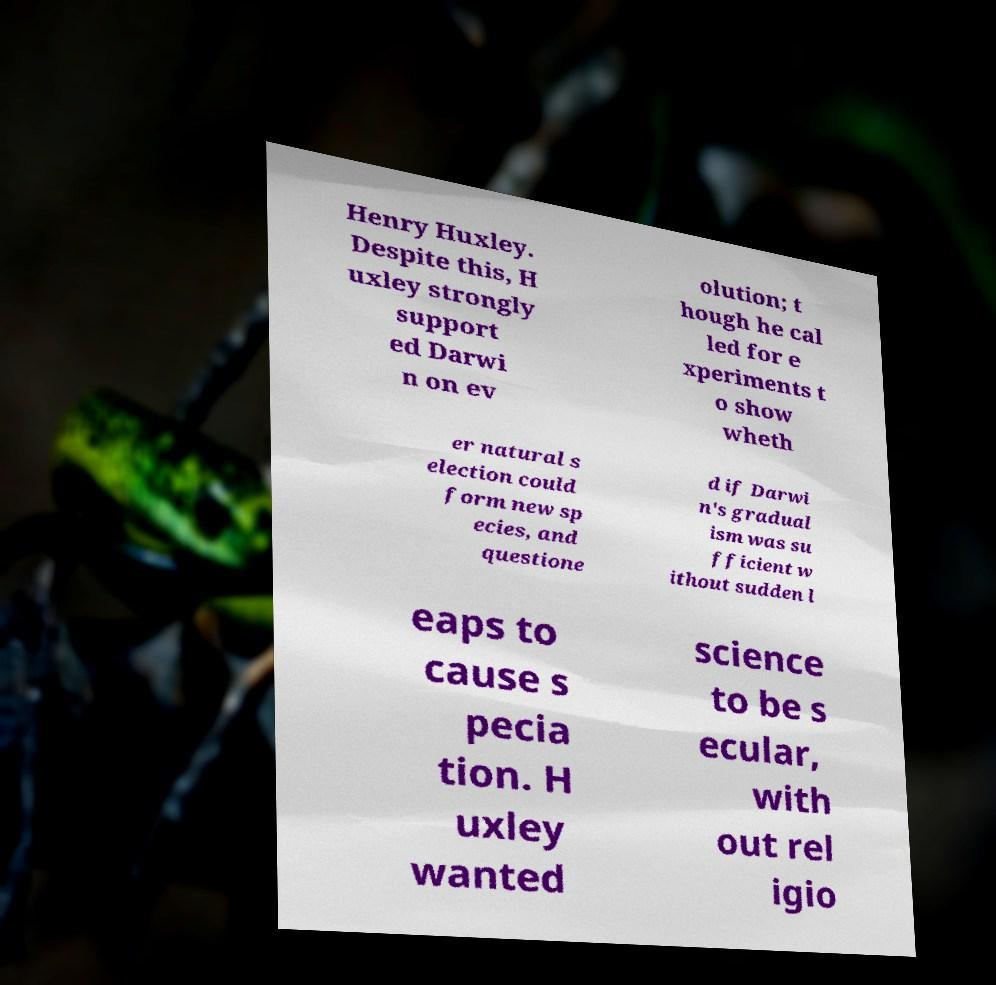I need the written content from this picture converted into text. Can you do that? Henry Huxley. Despite this, H uxley strongly support ed Darwi n on ev olution; t hough he cal led for e xperiments t o show wheth er natural s election could form new sp ecies, and questione d if Darwi n's gradual ism was su fficient w ithout sudden l eaps to cause s pecia tion. H uxley wanted science to be s ecular, with out rel igio 